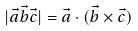Convert formula to latex. <formula><loc_0><loc_0><loc_500><loc_500>| \vec { a } \vec { b } \vec { c } | = \vec { a } \cdot ( \vec { b } \times \vec { c } )</formula> 